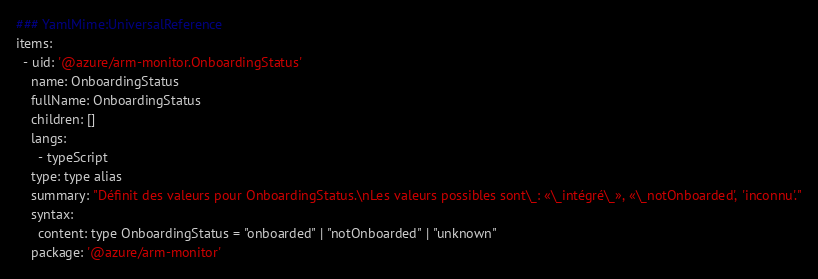Convert code to text. <code><loc_0><loc_0><loc_500><loc_500><_YAML_>### YamlMime:UniversalReference
items:
  - uid: '@azure/arm-monitor.OnboardingStatus'
    name: OnboardingStatus
    fullName: OnboardingStatus
    children: []
    langs:
      - typeScript
    type: type alias
    summary: "Définit des valeurs pour OnboardingStatus.\nLes valeurs possibles sont\_: «\_intégré\_», «\_notOnboarded', 'inconnu'."
    syntax:
      content: type OnboardingStatus = "onboarded" | "notOnboarded" | "unknown"
    package: '@azure/arm-monitor'</code> 